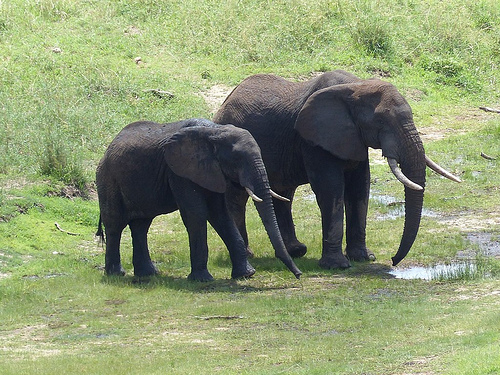What is the large elephant drinking from? The large elephant is drinking from a puddle of water on the ground. 